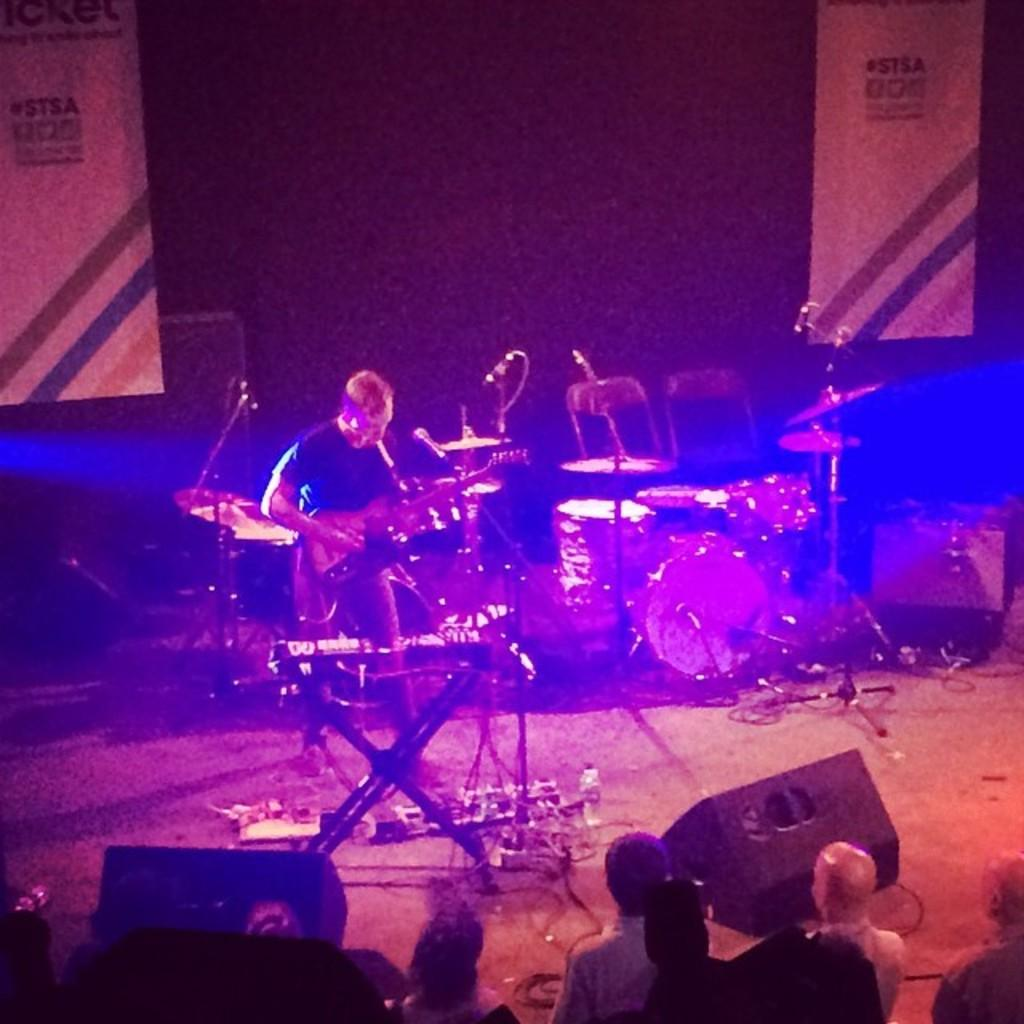How many people are in the image? There are people in the image, but the exact number is not specified. What is one person doing in the image? One person is playing a guitar. What else can be seen in the image besides people? There are musical instruments, stands, and microphones in the image. What is the setting of the image? The image appears to be set on a stage, as indicated by the presence of stands and microphones. What type of glove is being used to make observations in the image? There is no glove or observation activity present in the image. What time of day is it in the image? The time of day is not specified in the image. 